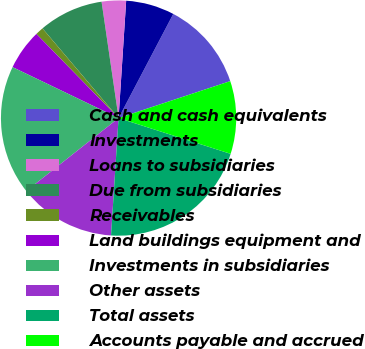Convert chart. <chart><loc_0><loc_0><loc_500><loc_500><pie_chart><fcel>Cash and cash equivalents<fcel>Investments<fcel>Loans to subsidiaries<fcel>Due from subsidiaries<fcel>Receivables<fcel>Land buildings equipment and<fcel>Investments in subsidiaries<fcel>Other assets<fcel>Total assets<fcel>Accounts payable and accrued<nl><fcel>12.22%<fcel>6.67%<fcel>3.34%<fcel>8.89%<fcel>1.11%<fcel>5.56%<fcel>17.78%<fcel>13.33%<fcel>21.11%<fcel>10.0%<nl></chart> 